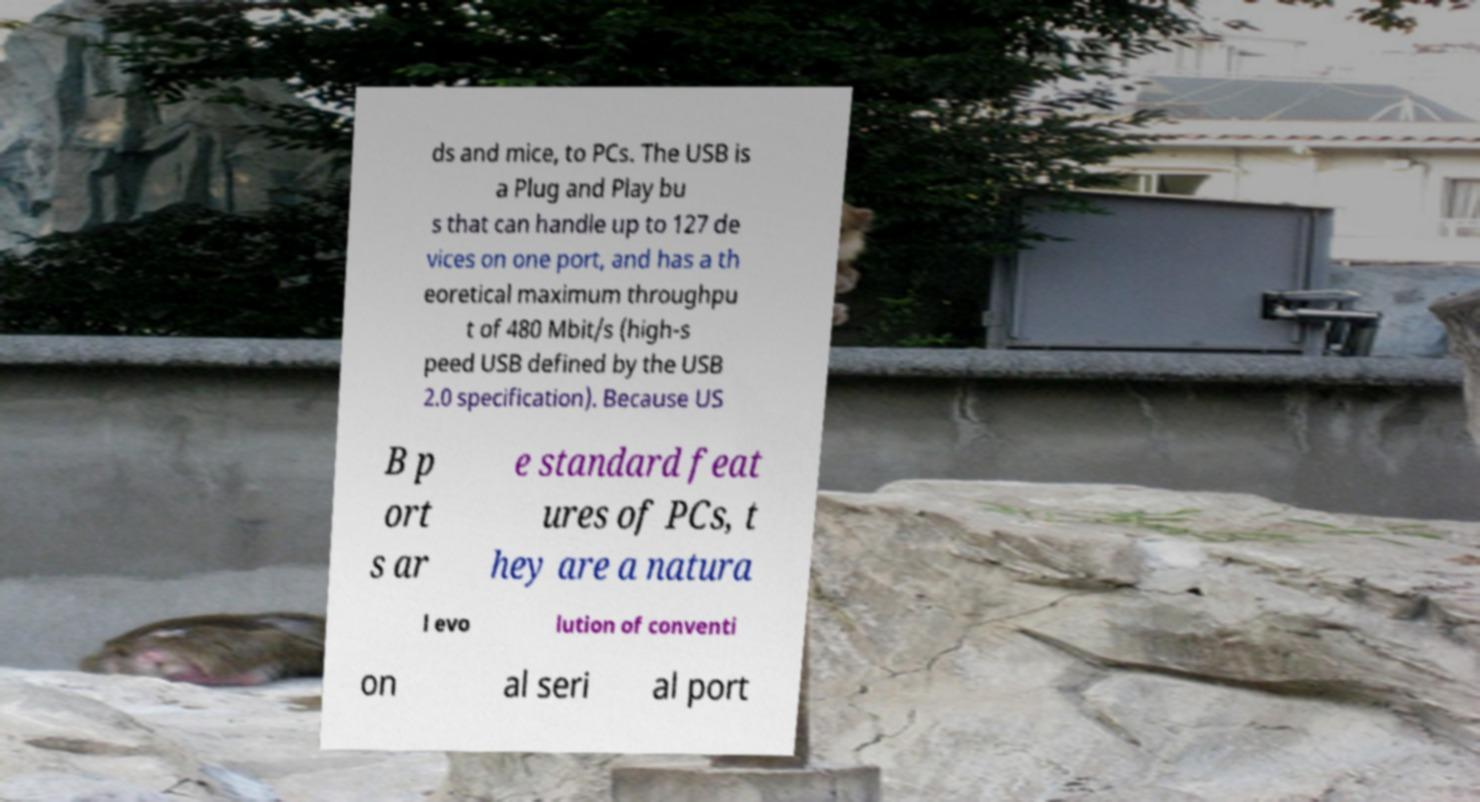What messages or text are displayed in this image? I need them in a readable, typed format. ds and mice, to PCs. The USB is a Plug and Play bu s that can handle up to 127 de vices on one port, and has a th eoretical maximum throughpu t of 480 Mbit/s (high-s peed USB defined by the USB 2.0 specification). Because US B p ort s ar e standard feat ures of PCs, t hey are a natura l evo lution of conventi on al seri al port 